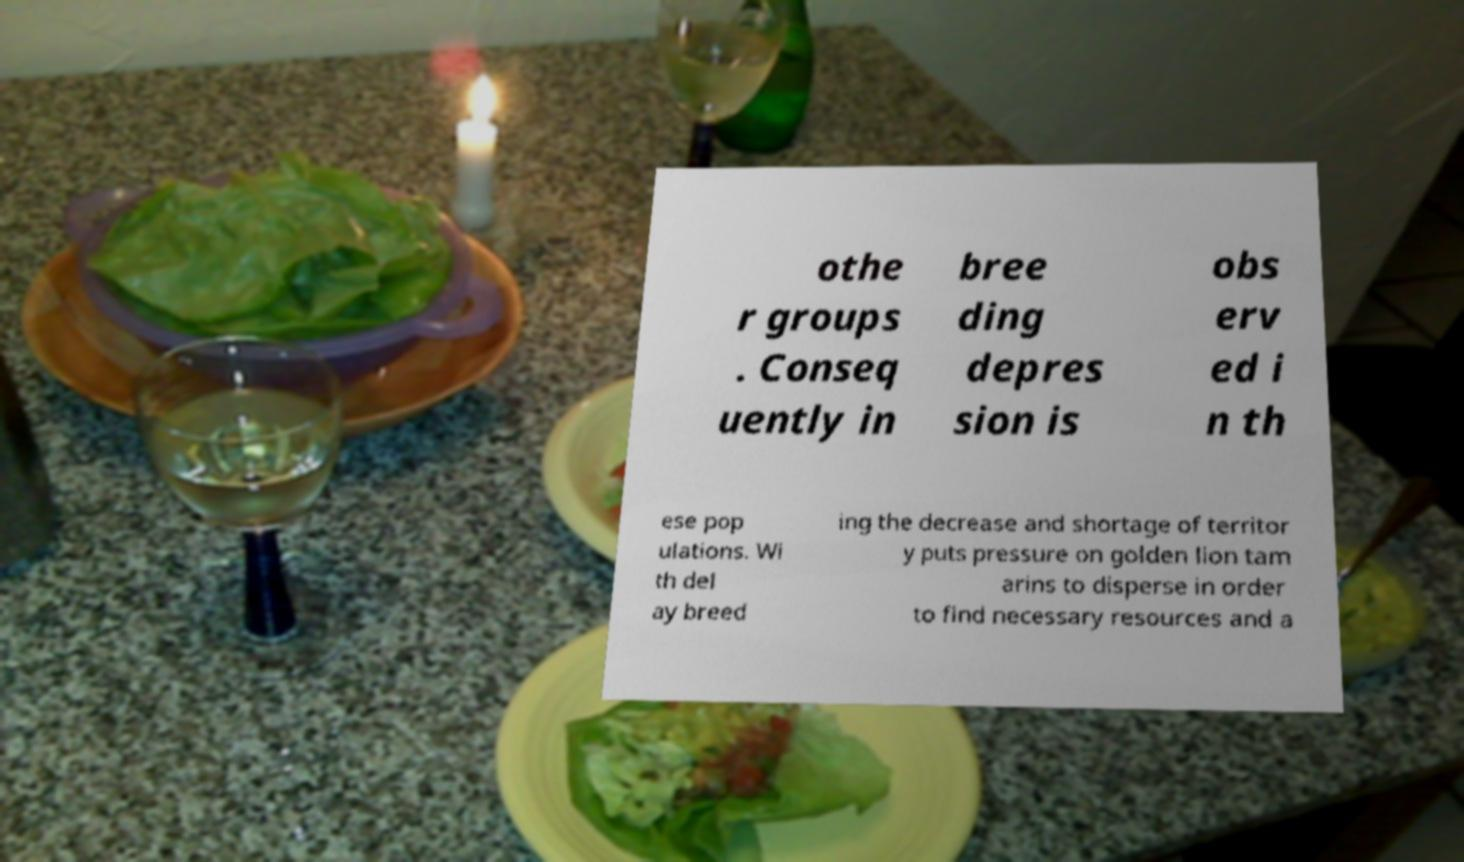Can you read and provide the text displayed in the image?This photo seems to have some interesting text. Can you extract and type it out for me? othe r groups . Conseq uently in bree ding depres sion is obs erv ed i n th ese pop ulations. Wi th del ay breed ing the decrease and shortage of territor y puts pressure on golden lion tam arins to disperse in order to find necessary resources and a 